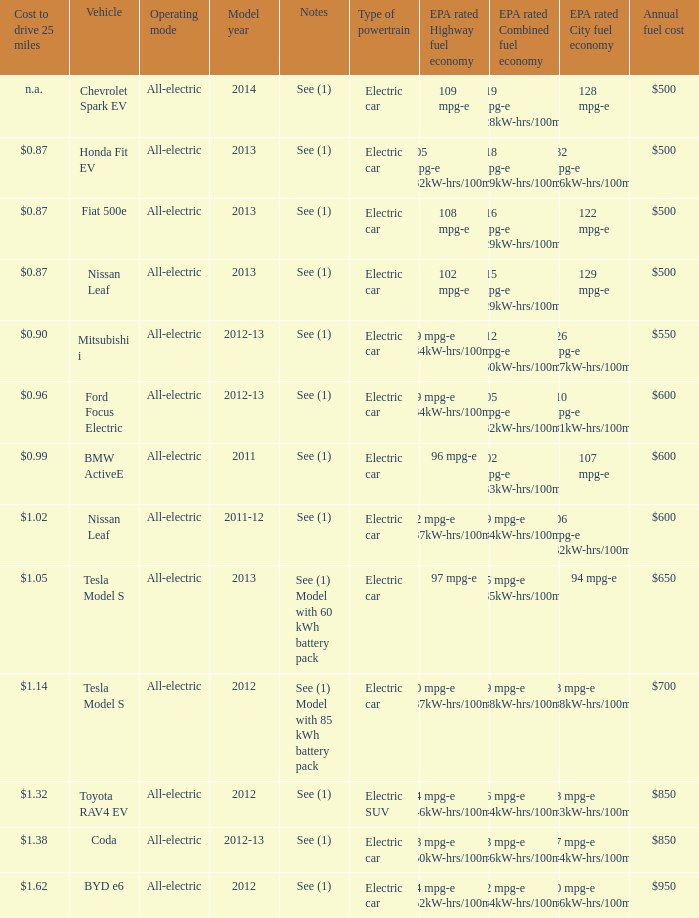What vehicle has an epa highway fuel economy of 109 mpg-e? Chevrolet Spark EV. 